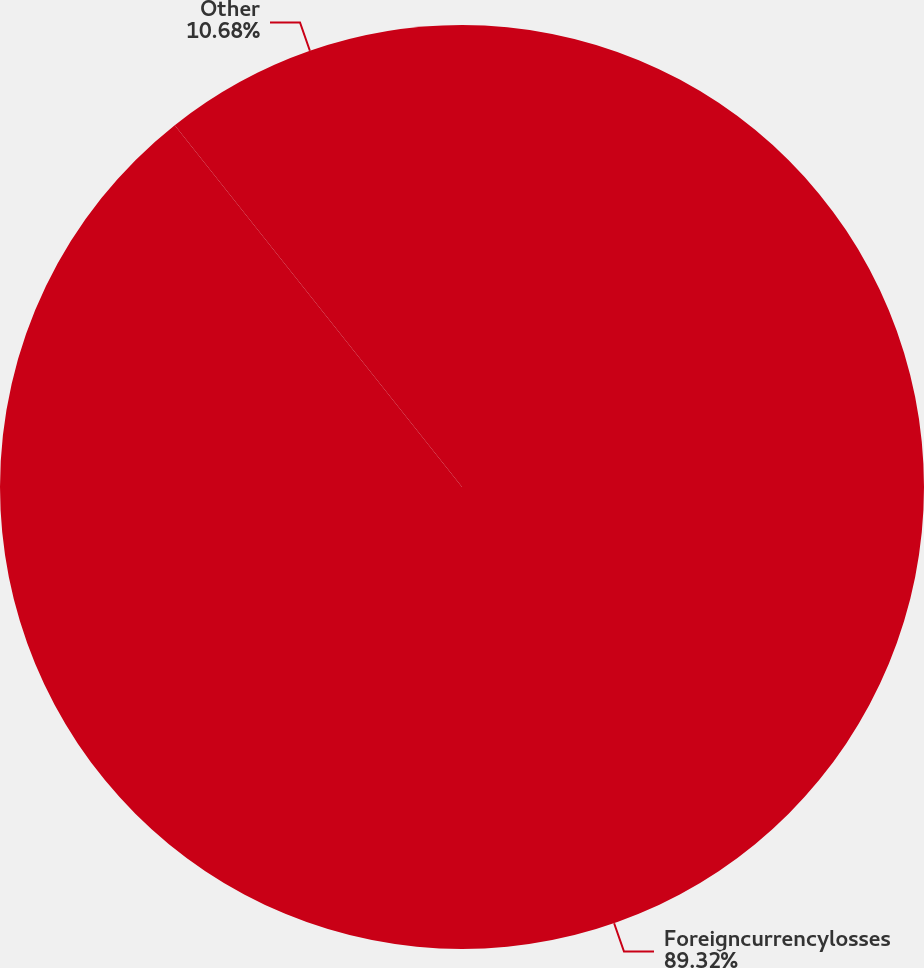Convert chart to OTSL. <chart><loc_0><loc_0><loc_500><loc_500><pie_chart><fcel>Foreigncurrencylosses<fcel>Other<nl><fcel>89.32%<fcel>10.68%<nl></chart> 